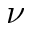<formula> <loc_0><loc_0><loc_500><loc_500>\nu</formula> 